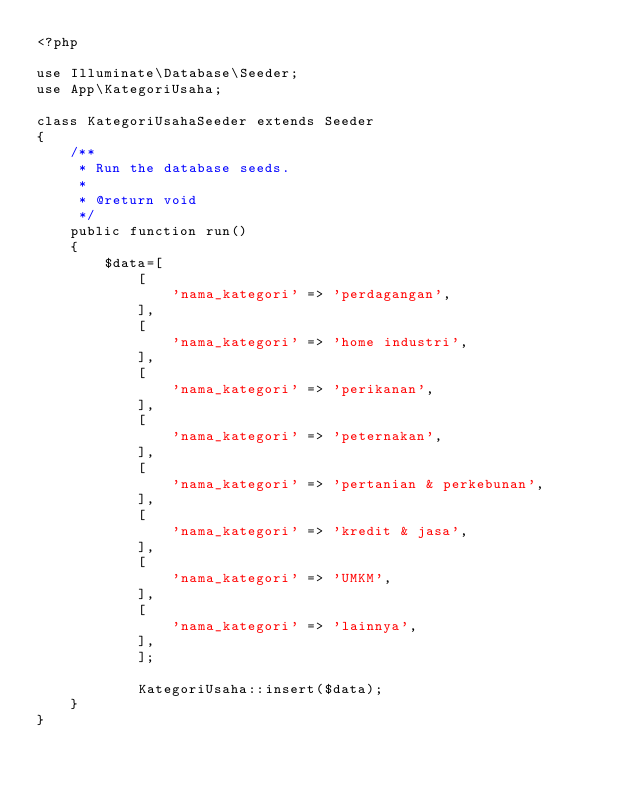Convert code to text. <code><loc_0><loc_0><loc_500><loc_500><_PHP_><?php

use Illuminate\Database\Seeder;
use App\KategoriUsaha;

class KategoriUsahaSeeder extends Seeder
{
    /**
     * Run the database seeds.
     *
     * @return void
     */
    public function run()
    {
        $data=[
            [
                'nama_kategori' => 'perdagangan',
            ],
            [
                'nama_kategori' => 'home industri',
            ],
            [
                'nama_kategori' => 'perikanan',
            ],
            [
                'nama_kategori' => 'peternakan',
            ],
            [
                'nama_kategori' => 'pertanian & perkebunan',
            ],
            [
                'nama_kategori' => 'kredit & jasa',
            ],
            [
                'nama_kategori' => 'UMKM',
            ],
            [
                'nama_kategori' => 'lainnya',
            ],
            ];

            KategoriUsaha::insert($data);
    }
}
</code> 